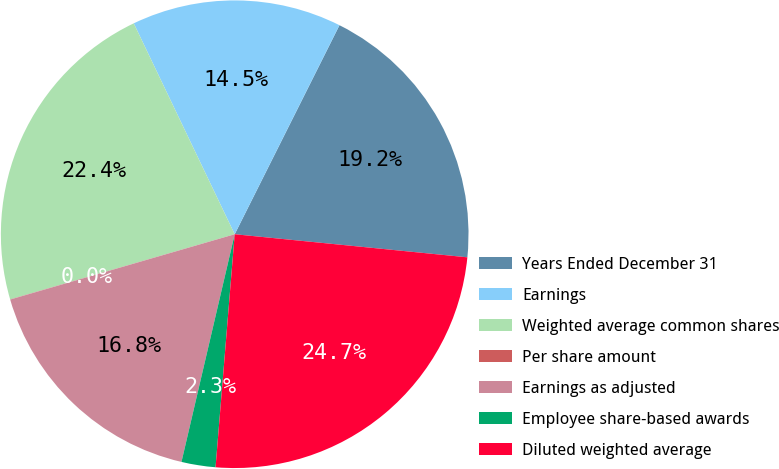Convert chart. <chart><loc_0><loc_0><loc_500><loc_500><pie_chart><fcel>Years Ended December 31<fcel>Earnings<fcel>Weighted average common shares<fcel>Per share amount<fcel>Earnings as adjusted<fcel>Employee share-based awards<fcel>Diluted weighted average<nl><fcel>19.18%<fcel>14.5%<fcel>22.39%<fcel>0.01%<fcel>16.84%<fcel>2.35%<fcel>24.73%<nl></chart> 